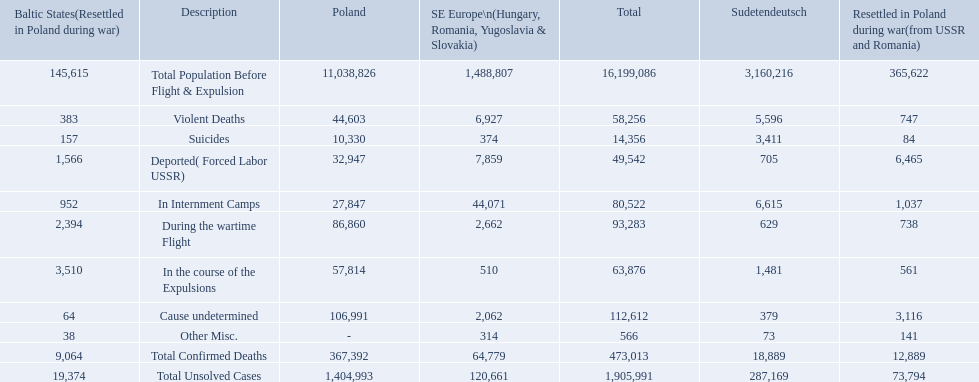What were all of the types of deaths? Violent Deaths, Suicides, Deported( Forced Labor USSR), In Internment Camps, During the wartime Flight, In the course of the Expulsions, Cause undetermined, Other Misc. And their totals in the baltic states? 383, 157, 1,566, 952, 2,394, 3,510, 64, 38. Were more deaths in the baltic states caused by undetermined causes or misc.? Cause undetermined. 